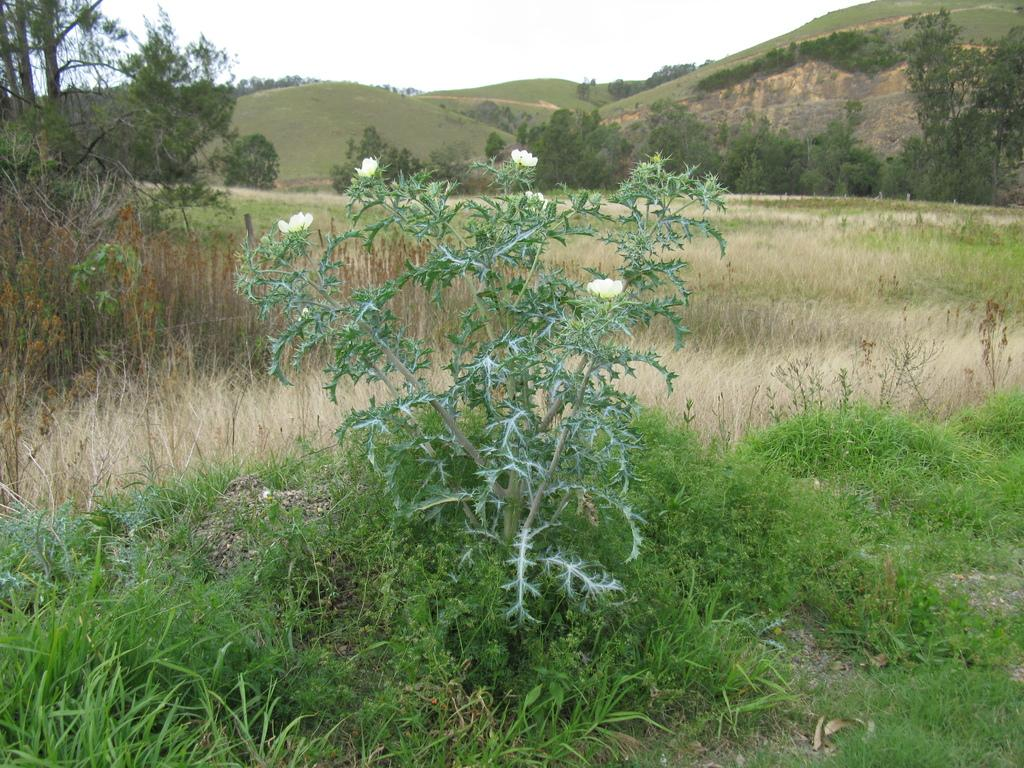What type of plant can be seen in the image? There is a plant with flowers in the image. What is on the ground in the image? There is grass on the ground in the image. What can be seen in the background of the image? There are trees, hills, and the sky visible in the background of the image. What health benefits does the jail provide to the people in the image? There is no jail present in the image, and therefore no health benefits or people associated with it can be observed. 